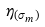Convert formula to latex. <formula><loc_0><loc_0><loc_500><loc_500>\eta _ { ( \sigma _ { m } ) }</formula> 